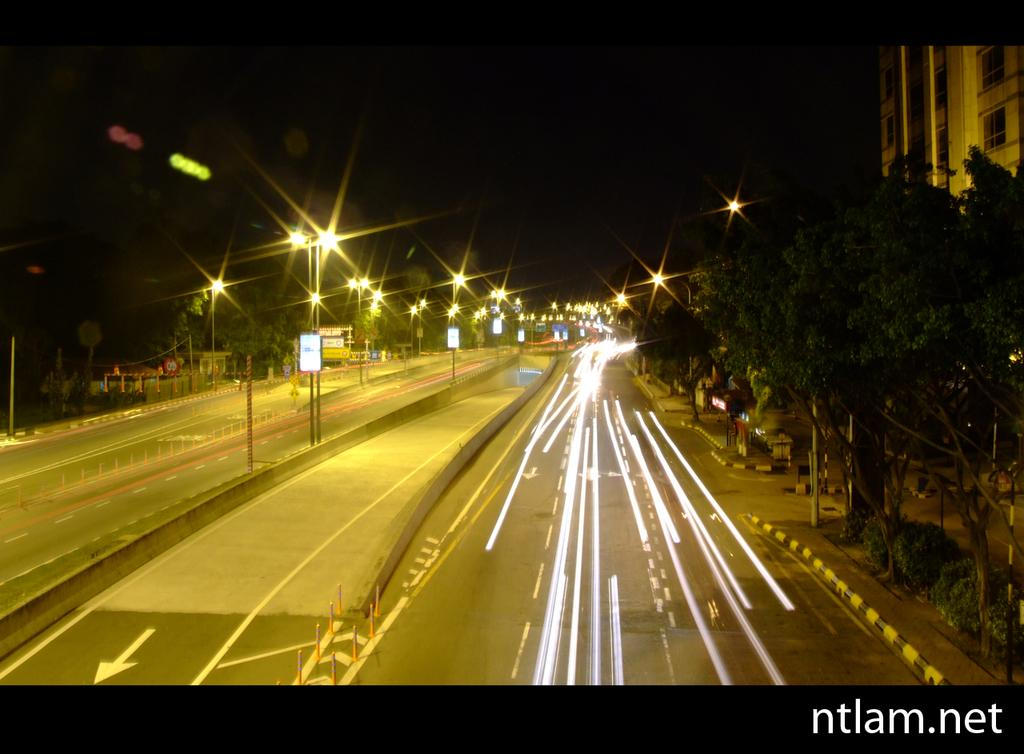What type of infrastructure is visible in the image? There are roads in the image. What feature can be seen along the roads? The roads have street lights. What type of vegetation is present alongside the roads? There are trees on either side of the roads. What structure is located in the right corner of the image? There is a building in the right corner of the image. What is the value of the wristwatch worn by the tree in the image? There are no wristwatches or trees wearing wristwatches present in the image. 